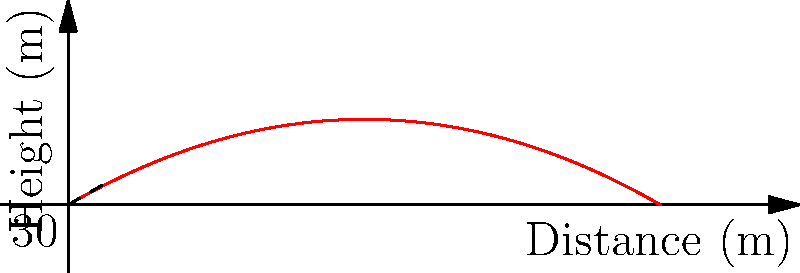Comrade Officer, you are tasked with calculating the maximum height reached by a projectile launched from our advanced artillery system. The projectile is fired with an initial velocity of 100 m/s at an angle of 30° above the horizontal. What is the maximum height reached by the projectile? Round your answer to the nearest meter. To solve this problem, we will follow these steps:

1) The maximum height is reached when the vertical component of velocity becomes zero. We can use the equation:

   $$v_y = v_0 \sin \theta - gt$$

   where $v_y$ is the vertical component of velocity, $v_0$ is the initial velocity, $\theta$ is the launch angle, $g$ is the acceleration due to gravity, and $t$ is time.

2) At the highest point, $v_y = 0$. So:

   $$0 = v_0 \sin \theta - gt_{max}$$

3) Solve for $t_{max}$:

   $$t_{max} = \frac{v_0 \sin \theta}{g}$$

4) Substitute the given values:

   $$t_{max} = \frac{100 \cdot \sin 30°}{9.8} \approx 5.10 \text{ seconds}$$

5) Now, use the equation for the height of the projectile:

   $$h = v_0 \sin \theta \cdot t - \frac{1}{2}gt^2$$

6) Substitute $t_{max}$ into this equation:

   $$h_{max} = 100 \cdot \sin 30° \cdot 5.10 - \frac{1}{2} \cdot 9.8 \cdot 5.10^2$$

7) Calculate:

   $$h_{max} = 255 - 127.5 = 127.5 \text{ meters}$$

8) Rounding to the nearest meter:

   $$h_{max} \approx 128 \text{ meters}$$
Answer: 128 meters 